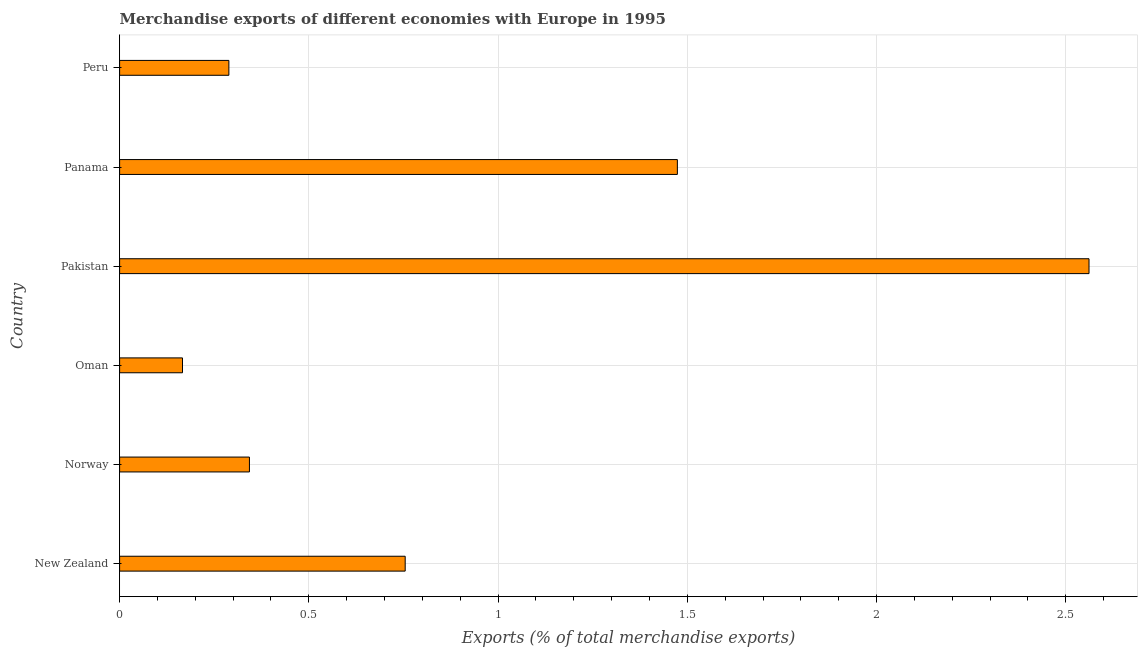Does the graph contain grids?
Offer a very short reply. Yes. What is the title of the graph?
Your answer should be very brief. Merchandise exports of different economies with Europe in 1995. What is the label or title of the X-axis?
Provide a short and direct response. Exports (% of total merchandise exports). What is the label or title of the Y-axis?
Give a very brief answer. Country. What is the merchandise exports in New Zealand?
Offer a terse response. 0.75. Across all countries, what is the maximum merchandise exports?
Provide a short and direct response. 2.56. Across all countries, what is the minimum merchandise exports?
Your answer should be very brief. 0.17. In which country was the merchandise exports maximum?
Your answer should be compact. Pakistan. In which country was the merchandise exports minimum?
Provide a short and direct response. Oman. What is the sum of the merchandise exports?
Give a very brief answer. 5.59. What is the difference between the merchandise exports in New Zealand and Panama?
Offer a terse response. -0.72. What is the average merchandise exports per country?
Ensure brevity in your answer.  0.93. What is the median merchandise exports?
Provide a short and direct response. 0.55. In how many countries, is the merchandise exports greater than 0.8 %?
Your answer should be compact. 2. What is the ratio of the merchandise exports in Norway to that in Oman?
Your answer should be compact. 2.06. Is the merchandise exports in New Zealand less than that in Panama?
Give a very brief answer. Yes. What is the difference between the highest and the second highest merchandise exports?
Provide a succinct answer. 1.09. What is the difference between the highest and the lowest merchandise exports?
Provide a succinct answer. 2.4. In how many countries, is the merchandise exports greater than the average merchandise exports taken over all countries?
Provide a succinct answer. 2. What is the difference between two consecutive major ticks on the X-axis?
Provide a short and direct response. 0.5. Are the values on the major ticks of X-axis written in scientific E-notation?
Offer a very short reply. No. What is the Exports (% of total merchandise exports) of New Zealand?
Offer a very short reply. 0.75. What is the Exports (% of total merchandise exports) of Norway?
Your answer should be very brief. 0.34. What is the Exports (% of total merchandise exports) in Oman?
Offer a very short reply. 0.17. What is the Exports (% of total merchandise exports) of Pakistan?
Your answer should be compact. 2.56. What is the Exports (% of total merchandise exports) in Panama?
Your answer should be very brief. 1.47. What is the Exports (% of total merchandise exports) in Peru?
Keep it short and to the point. 0.29. What is the difference between the Exports (% of total merchandise exports) in New Zealand and Norway?
Your answer should be very brief. 0.41. What is the difference between the Exports (% of total merchandise exports) in New Zealand and Oman?
Your answer should be very brief. 0.59. What is the difference between the Exports (% of total merchandise exports) in New Zealand and Pakistan?
Your response must be concise. -1.81. What is the difference between the Exports (% of total merchandise exports) in New Zealand and Panama?
Make the answer very short. -0.72. What is the difference between the Exports (% of total merchandise exports) in New Zealand and Peru?
Give a very brief answer. 0.47. What is the difference between the Exports (% of total merchandise exports) in Norway and Oman?
Your answer should be compact. 0.18. What is the difference between the Exports (% of total merchandise exports) in Norway and Pakistan?
Your response must be concise. -2.22. What is the difference between the Exports (% of total merchandise exports) in Norway and Panama?
Your answer should be very brief. -1.13. What is the difference between the Exports (% of total merchandise exports) in Norway and Peru?
Offer a very short reply. 0.05. What is the difference between the Exports (% of total merchandise exports) in Oman and Pakistan?
Keep it short and to the point. -2.4. What is the difference between the Exports (% of total merchandise exports) in Oman and Panama?
Your answer should be compact. -1.31. What is the difference between the Exports (% of total merchandise exports) in Oman and Peru?
Your response must be concise. -0.12. What is the difference between the Exports (% of total merchandise exports) in Pakistan and Panama?
Keep it short and to the point. 1.09. What is the difference between the Exports (% of total merchandise exports) in Pakistan and Peru?
Offer a very short reply. 2.27. What is the difference between the Exports (% of total merchandise exports) in Panama and Peru?
Provide a succinct answer. 1.19. What is the ratio of the Exports (% of total merchandise exports) in New Zealand to that in Norway?
Ensure brevity in your answer.  2.2. What is the ratio of the Exports (% of total merchandise exports) in New Zealand to that in Oman?
Your answer should be very brief. 4.54. What is the ratio of the Exports (% of total merchandise exports) in New Zealand to that in Pakistan?
Provide a succinct answer. 0.29. What is the ratio of the Exports (% of total merchandise exports) in New Zealand to that in Panama?
Give a very brief answer. 0.51. What is the ratio of the Exports (% of total merchandise exports) in New Zealand to that in Peru?
Provide a short and direct response. 2.61. What is the ratio of the Exports (% of total merchandise exports) in Norway to that in Oman?
Provide a succinct answer. 2.06. What is the ratio of the Exports (% of total merchandise exports) in Norway to that in Pakistan?
Offer a very short reply. 0.13. What is the ratio of the Exports (% of total merchandise exports) in Norway to that in Panama?
Your response must be concise. 0.23. What is the ratio of the Exports (% of total merchandise exports) in Norway to that in Peru?
Provide a succinct answer. 1.19. What is the ratio of the Exports (% of total merchandise exports) in Oman to that in Pakistan?
Your response must be concise. 0.07. What is the ratio of the Exports (% of total merchandise exports) in Oman to that in Panama?
Your response must be concise. 0.11. What is the ratio of the Exports (% of total merchandise exports) in Oman to that in Peru?
Your response must be concise. 0.58. What is the ratio of the Exports (% of total merchandise exports) in Pakistan to that in Panama?
Make the answer very short. 1.74. What is the ratio of the Exports (% of total merchandise exports) in Pakistan to that in Peru?
Keep it short and to the point. 8.87. What is the ratio of the Exports (% of total merchandise exports) in Panama to that in Peru?
Offer a very short reply. 5.11. 